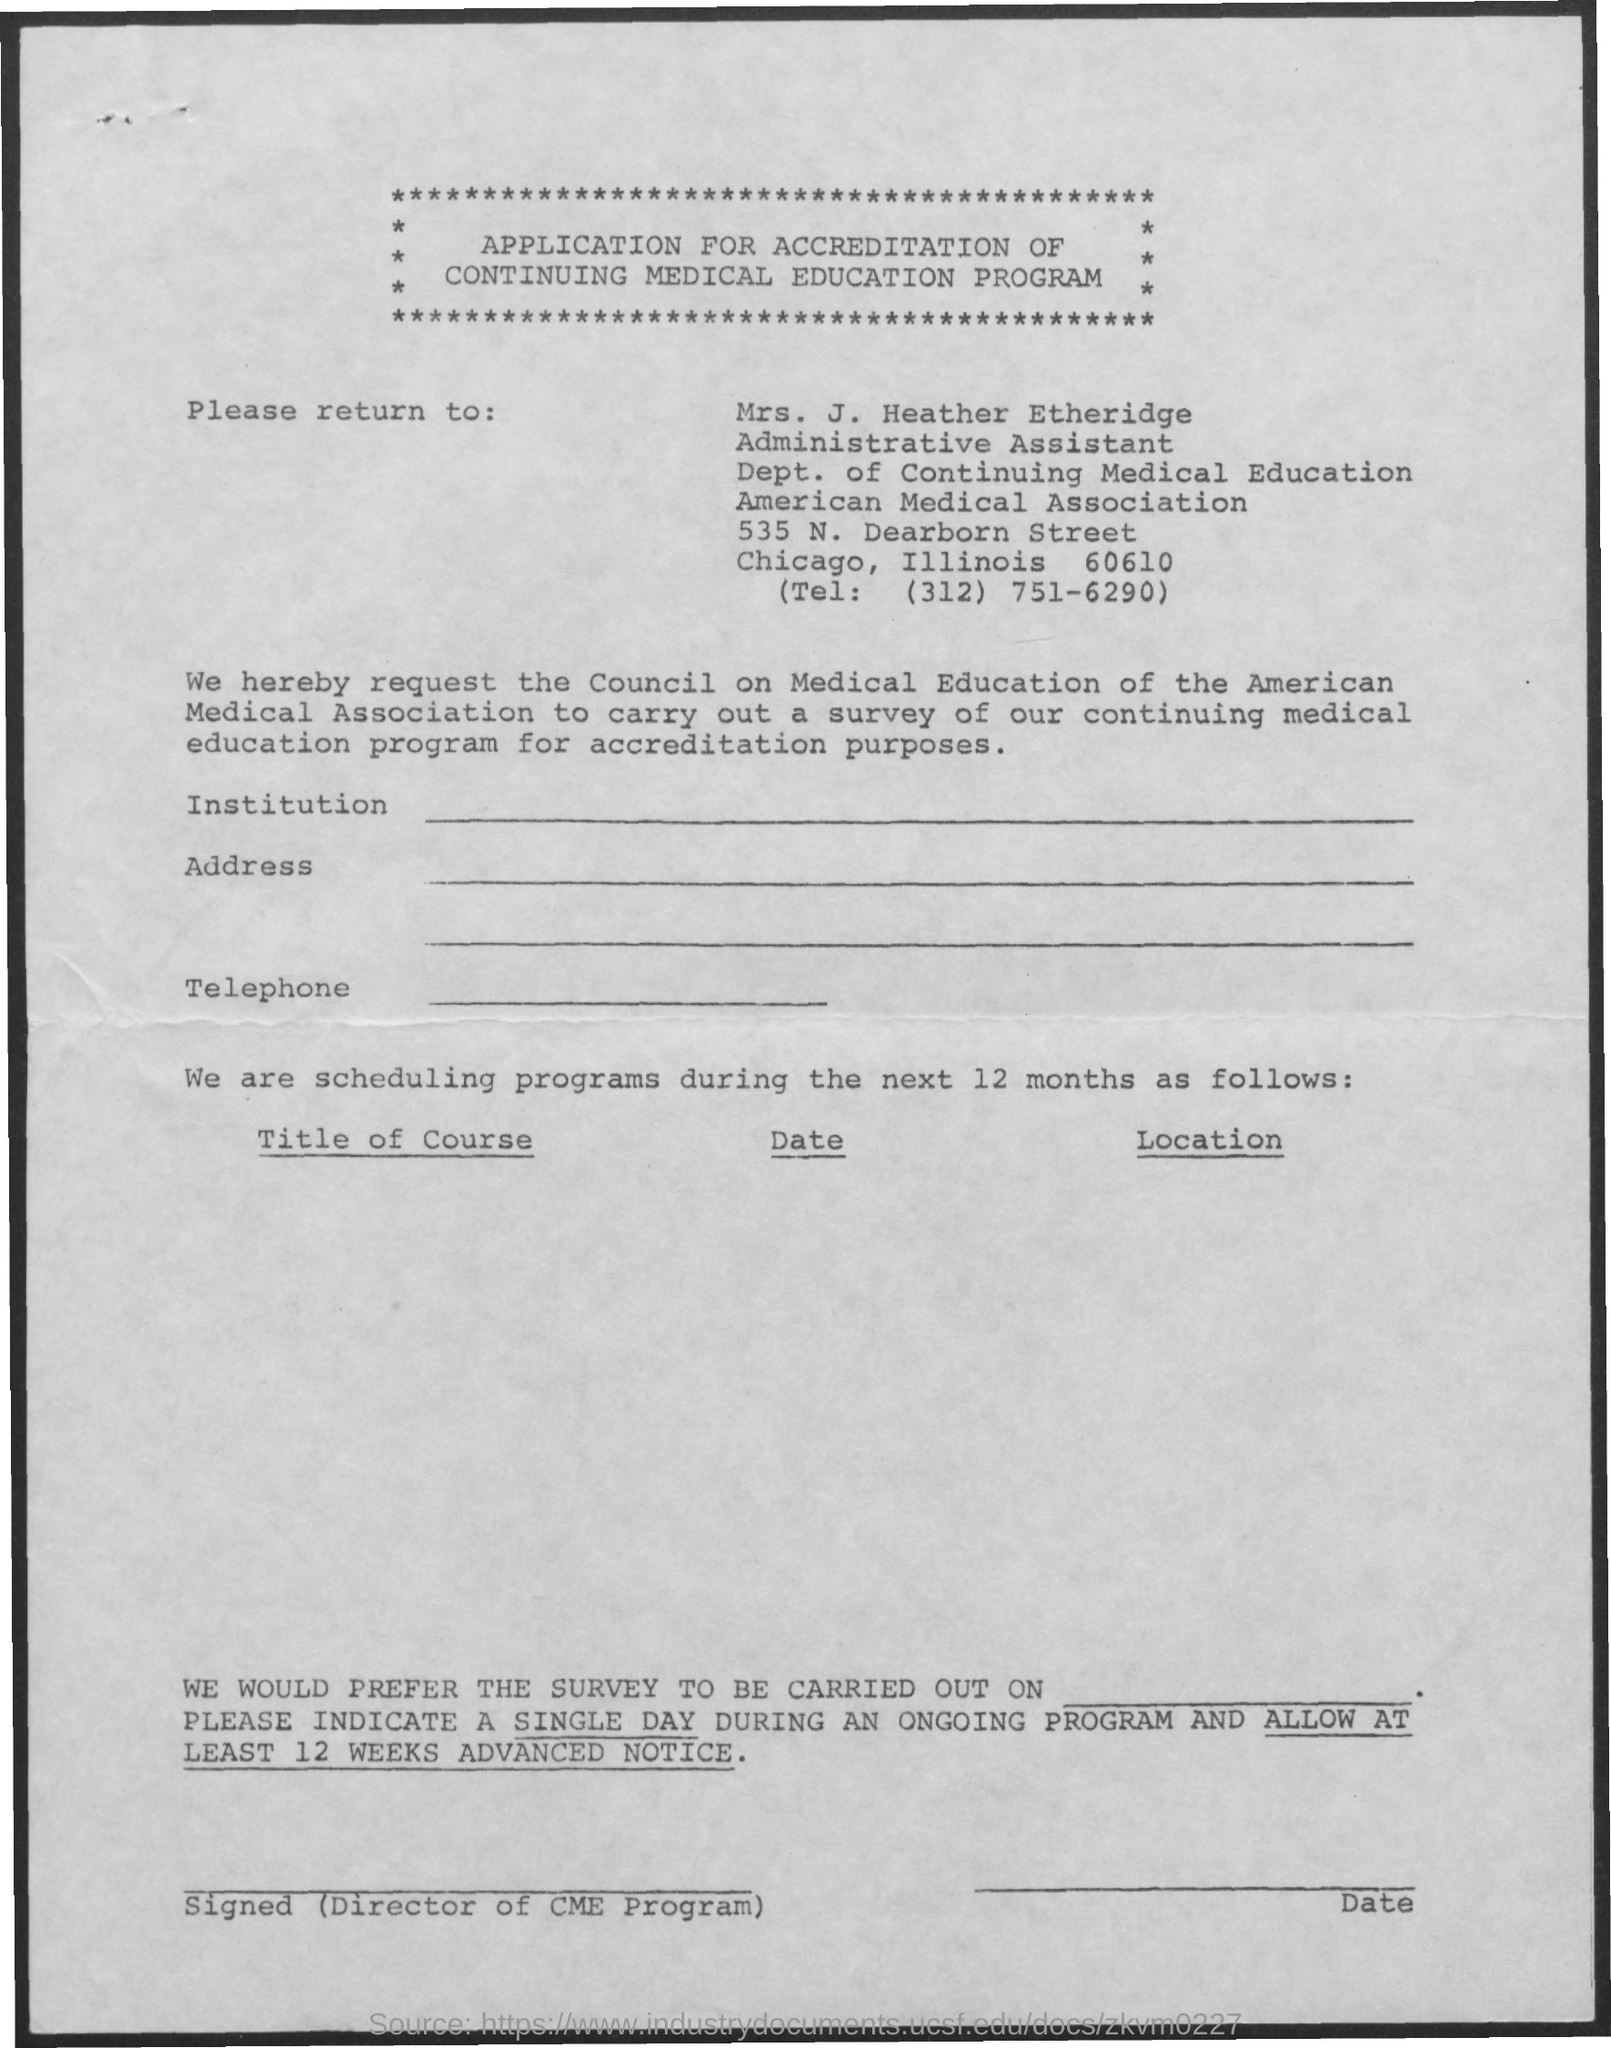Highlight a few significant elements in this photo. This document pertains to an application for accreditation of a Continuing Medical Education program. Mrs. J. Heather Etheridge holds the designation of an administrative assistant. The telephone number given in the form is (312) 751-6290. The form should be returned to Mrs. J. Heather Etheridge. 